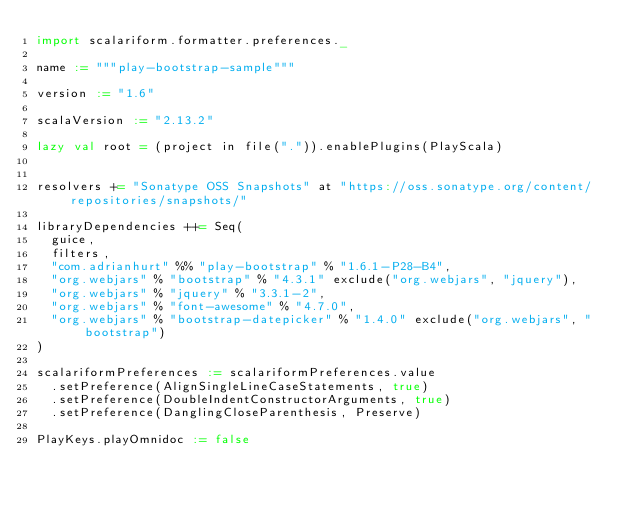<code> <loc_0><loc_0><loc_500><loc_500><_Scala_>import scalariform.formatter.preferences._

name := """play-bootstrap-sample"""

version := "1.6"

scalaVersion := "2.13.2"

lazy val root = (project in file(".")).enablePlugins(PlayScala)


resolvers += "Sonatype OSS Snapshots" at "https://oss.sonatype.org/content/repositories/snapshots/"

libraryDependencies ++= Seq(
  guice,
  filters,
  "com.adrianhurt" %% "play-bootstrap" % "1.6.1-P28-B4",
  "org.webjars" % "bootstrap" % "4.3.1" exclude("org.webjars", "jquery"),
  "org.webjars" % "jquery" % "3.3.1-2",
  "org.webjars" % "font-awesome" % "4.7.0",
  "org.webjars" % "bootstrap-datepicker" % "1.4.0" exclude("org.webjars", "bootstrap")
)

scalariformPreferences := scalariformPreferences.value
  .setPreference(AlignSingleLineCaseStatements, true)
  .setPreference(DoubleIndentConstructorArguments, true)
  .setPreference(DanglingCloseParenthesis, Preserve)

PlayKeys.playOmnidoc := false</code> 